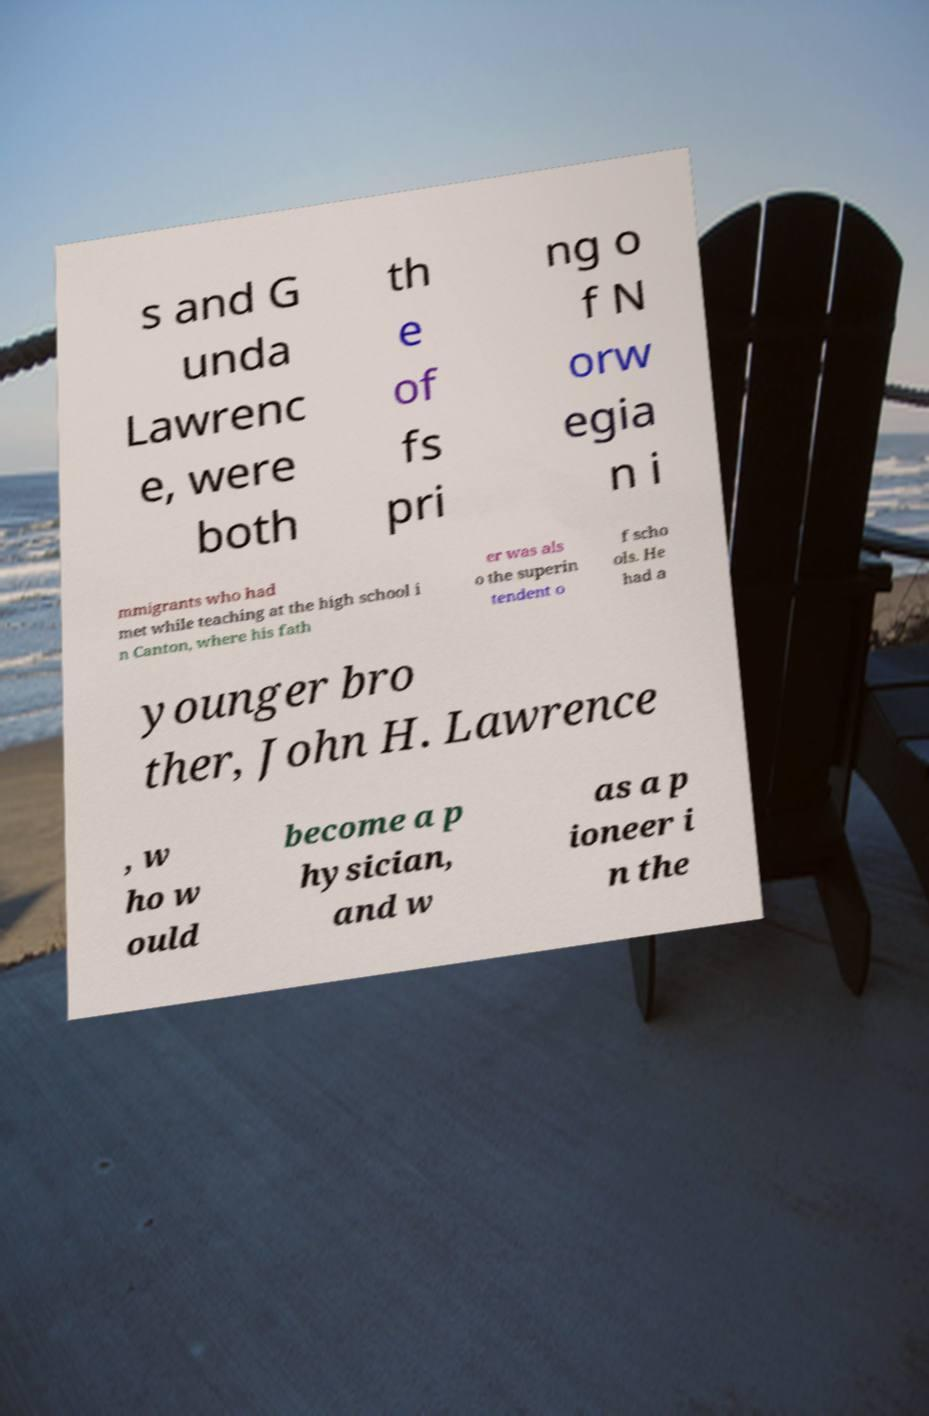Can you read and provide the text displayed in the image?This photo seems to have some interesting text. Can you extract and type it out for me? s and G unda Lawrenc e, were both th e of fs pri ng o f N orw egia n i mmigrants who had met while teaching at the high school i n Canton, where his fath er was als o the superin tendent o f scho ols. He had a younger bro ther, John H. Lawrence , w ho w ould become a p hysician, and w as a p ioneer i n the 